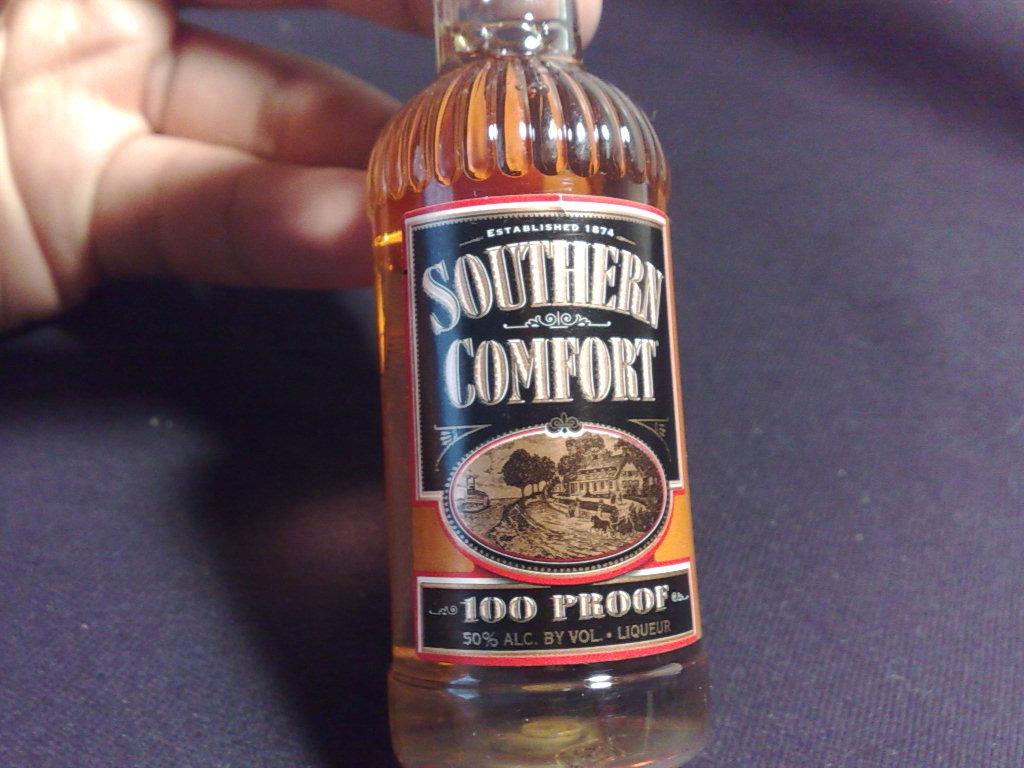How much alcohol is there by volume?
Ensure brevity in your answer.  50%. What is the name of this liquor?
Your answer should be compact. Southern comfort. 